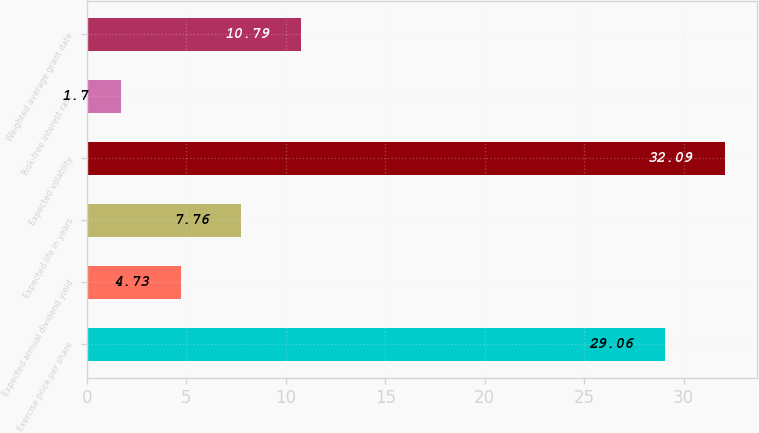Convert chart to OTSL. <chart><loc_0><loc_0><loc_500><loc_500><bar_chart><fcel>Exercise price per share<fcel>Expected annual dividend yield<fcel>Expected life in years<fcel>Expected volatility<fcel>Risk-free interest rate<fcel>Weighted average grant date<nl><fcel>29.06<fcel>4.73<fcel>7.76<fcel>32.09<fcel>1.7<fcel>10.79<nl></chart> 